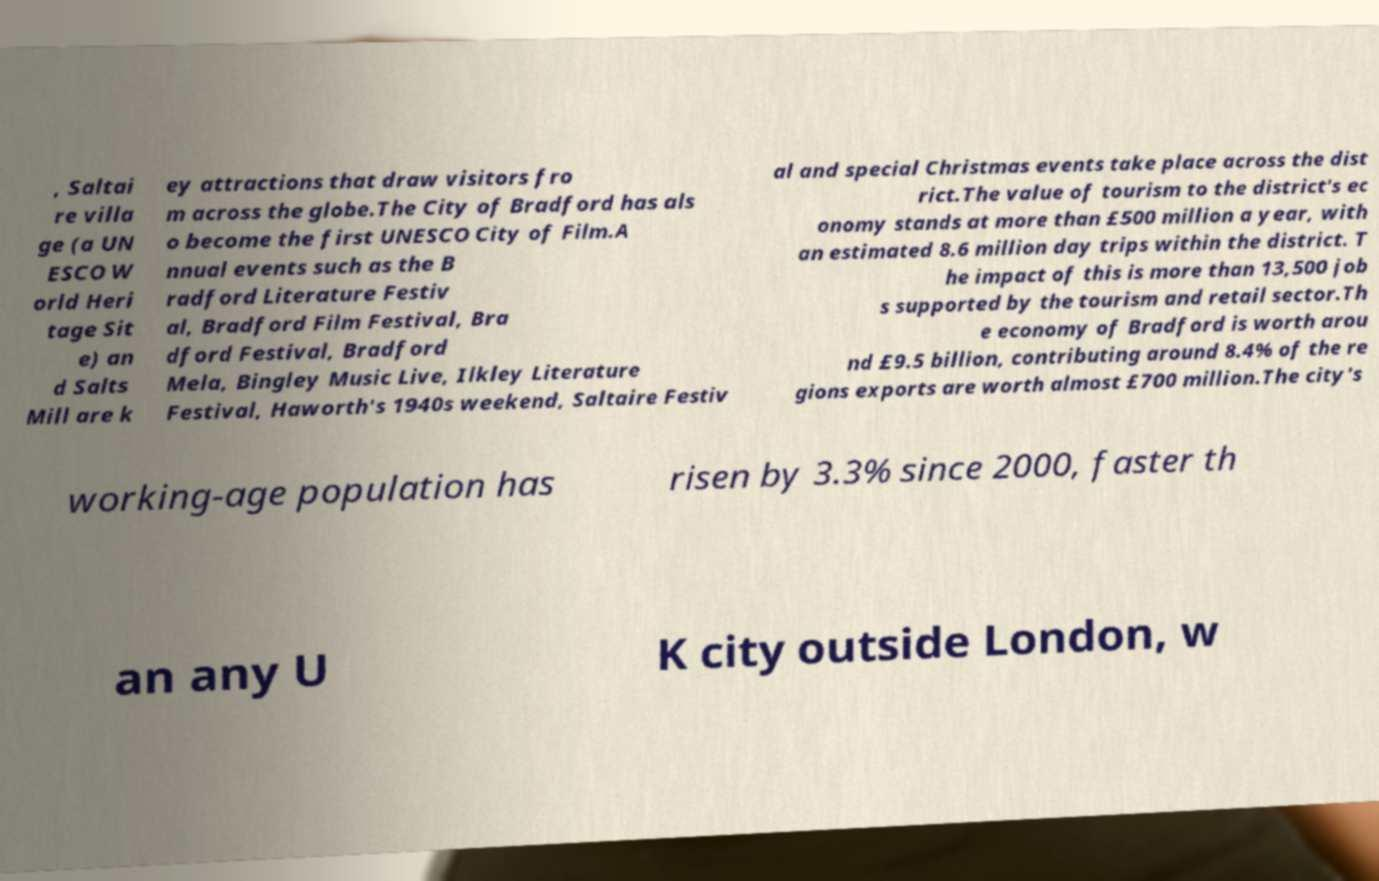Can you read and provide the text displayed in the image?This photo seems to have some interesting text. Can you extract and type it out for me? , Saltai re villa ge (a UN ESCO W orld Heri tage Sit e) an d Salts Mill are k ey attractions that draw visitors fro m across the globe.The City of Bradford has als o become the first UNESCO City of Film.A nnual events such as the B radford Literature Festiv al, Bradford Film Festival, Bra dford Festival, Bradford Mela, Bingley Music Live, Ilkley Literature Festival, Haworth's 1940s weekend, Saltaire Festiv al and special Christmas events take place across the dist rict.The value of tourism to the district's ec onomy stands at more than £500 million a year, with an estimated 8.6 million day trips within the district. T he impact of this is more than 13,500 job s supported by the tourism and retail sector.Th e economy of Bradford is worth arou nd £9.5 billion, contributing around 8.4% of the re gions exports are worth almost £700 million.The city's working-age population has risen by 3.3% since 2000, faster th an any U K city outside London, w 